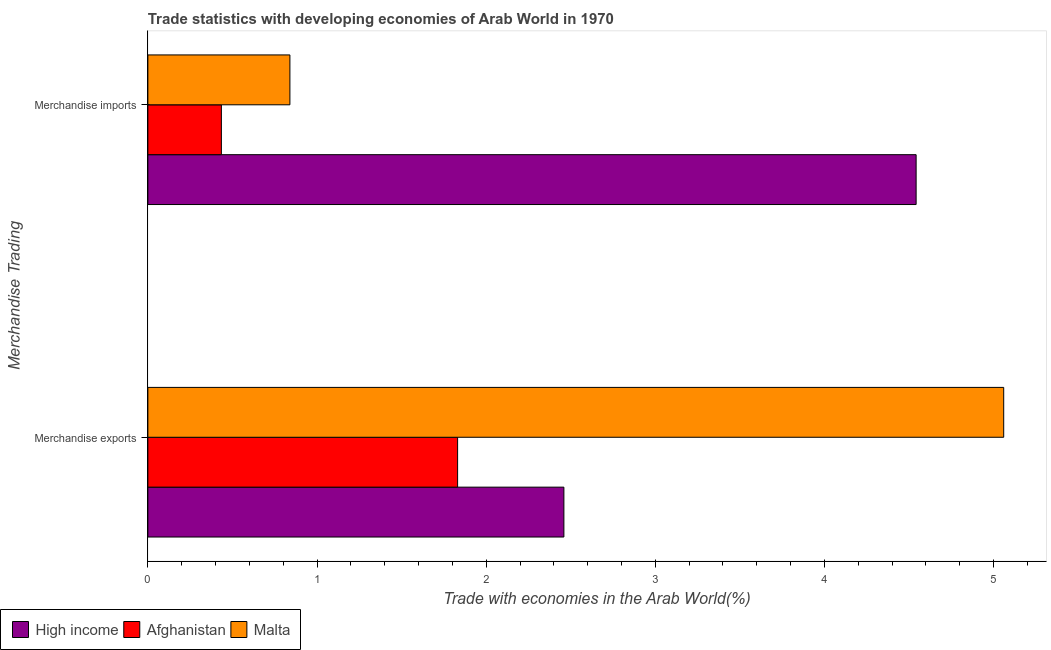Are the number of bars per tick equal to the number of legend labels?
Offer a terse response. Yes. Are the number of bars on each tick of the Y-axis equal?
Provide a short and direct response. Yes. How many bars are there on the 2nd tick from the bottom?
Keep it short and to the point. 3. What is the merchandise imports in Malta?
Provide a succinct answer. 0.84. Across all countries, what is the maximum merchandise imports?
Offer a terse response. 4.54. Across all countries, what is the minimum merchandise exports?
Provide a succinct answer. 1.83. In which country was the merchandise imports minimum?
Your answer should be very brief. Afghanistan. What is the total merchandise exports in the graph?
Your answer should be very brief. 9.35. What is the difference between the merchandise exports in High income and that in Afghanistan?
Your answer should be compact. 0.63. What is the difference between the merchandise exports in Afghanistan and the merchandise imports in Malta?
Give a very brief answer. 0.99. What is the average merchandise imports per country?
Offer a terse response. 1.94. What is the difference between the merchandise imports and merchandise exports in High income?
Provide a succinct answer. 2.08. In how many countries, is the merchandise imports greater than 0.2 %?
Make the answer very short. 3. What is the ratio of the merchandise exports in Afghanistan to that in Malta?
Provide a short and direct response. 0.36. In how many countries, is the merchandise exports greater than the average merchandise exports taken over all countries?
Your response must be concise. 1. What does the 1st bar from the top in Merchandise imports represents?
Provide a succinct answer. Malta. How many bars are there?
Provide a short and direct response. 6. How many countries are there in the graph?
Provide a short and direct response. 3. What is the difference between two consecutive major ticks on the X-axis?
Ensure brevity in your answer.  1. Does the graph contain grids?
Keep it short and to the point. No. Where does the legend appear in the graph?
Offer a very short reply. Bottom left. How are the legend labels stacked?
Keep it short and to the point. Horizontal. What is the title of the graph?
Provide a succinct answer. Trade statistics with developing economies of Arab World in 1970. Does "Jordan" appear as one of the legend labels in the graph?
Provide a short and direct response. No. What is the label or title of the X-axis?
Your answer should be compact. Trade with economies in the Arab World(%). What is the label or title of the Y-axis?
Offer a very short reply. Merchandise Trading. What is the Trade with economies in the Arab World(%) of High income in Merchandise exports?
Your response must be concise. 2.46. What is the Trade with economies in the Arab World(%) in Afghanistan in Merchandise exports?
Your answer should be compact. 1.83. What is the Trade with economies in the Arab World(%) in Malta in Merchandise exports?
Provide a short and direct response. 5.06. What is the Trade with economies in the Arab World(%) in High income in Merchandise imports?
Your response must be concise. 4.54. What is the Trade with economies in the Arab World(%) of Afghanistan in Merchandise imports?
Keep it short and to the point. 0.43. What is the Trade with economies in the Arab World(%) in Malta in Merchandise imports?
Keep it short and to the point. 0.84. Across all Merchandise Trading, what is the maximum Trade with economies in the Arab World(%) in High income?
Provide a short and direct response. 4.54. Across all Merchandise Trading, what is the maximum Trade with economies in the Arab World(%) of Afghanistan?
Your response must be concise. 1.83. Across all Merchandise Trading, what is the maximum Trade with economies in the Arab World(%) of Malta?
Your answer should be compact. 5.06. Across all Merchandise Trading, what is the minimum Trade with economies in the Arab World(%) in High income?
Provide a short and direct response. 2.46. Across all Merchandise Trading, what is the minimum Trade with economies in the Arab World(%) in Afghanistan?
Keep it short and to the point. 0.43. Across all Merchandise Trading, what is the minimum Trade with economies in the Arab World(%) in Malta?
Provide a short and direct response. 0.84. What is the total Trade with economies in the Arab World(%) of High income in the graph?
Provide a succinct answer. 7. What is the total Trade with economies in the Arab World(%) in Afghanistan in the graph?
Keep it short and to the point. 2.27. What is the total Trade with economies in the Arab World(%) of Malta in the graph?
Provide a short and direct response. 5.9. What is the difference between the Trade with economies in the Arab World(%) of High income in Merchandise exports and that in Merchandise imports?
Make the answer very short. -2.08. What is the difference between the Trade with economies in the Arab World(%) of Afghanistan in Merchandise exports and that in Merchandise imports?
Give a very brief answer. 1.4. What is the difference between the Trade with economies in the Arab World(%) in Malta in Merchandise exports and that in Merchandise imports?
Provide a short and direct response. 4.22. What is the difference between the Trade with economies in the Arab World(%) of High income in Merchandise exports and the Trade with economies in the Arab World(%) of Afghanistan in Merchandise imports?
Offer a very short reply. 2.02. What is the difference between the Trade with economies in the Arab World(%) in High income in Merchandise exports and the Trade with economies in the Arab World(%) in Malta in Merchandise imports?
Your answer should be very brief. 1.62. What is the difference between the Trade with economies in the Arab World(%) of Afghanistan in Merchandise exports and the Trade with economies in the Arab World(%) of Malta in Merchandise imports?
Your response must be concise. 0.99. What is the average Trade with economies in the Arab World(%) of High income per Merchandise Trading?
Offer a terse response. 3.5. What is the average Trade with economies in the Arab World(%) of Afghanistan per Merchandise Trading?
Offer a terse response. 1.13. What is the average Trade with economies in the Arab World(%) of Malta per Merchandise Trading?
Make the answer very short. 2.95. What is the difference between the Trade with economies in the Arab World(%) of High income and Trade with economies in the Arab World(%) of Afghanistan in Merchandise exports?
Offer a terse response. 0.63. What is the difference between the Trade with economies in the Arab World(%) in High income and Trade with economies in the Arab World(%) in Malta in Merchandise exports?
Ensure brevity in your answer.  -2.6. What is the difference between the Trade with economies in the Arab World(%) of Afghanistan and Trade with economies in the Arab World(%) of Malta in Merchandise exports?
Provide a succinct answer. -3.23. What is the difference between the Trade with economies in the Arab World(%) of High income and Trade with economies in the Arab World(%) of Afghanistan in Merchandise imports?
Ensure brevity in your answer.  4.11. What is the difference between the Trade with economies in the Arab World(%) in High income and Trade with economies in the Arab World(%) in Malta in Merchandise imports?
Ensure brevity in your answer.  3.7. What is the difference between the Trade with economies in the Arab World(%) of Afghanistan and Trade with economies in the Arab World(%) of Malta in Merchandise imports?
Make the answer very short. -0.41. What is the ratio of the Trade with economies in the Arab World(%) of High income in Merchandise exports to that in Merchandise imports?
Provide a short and direct response. 0.54. What is the ratio of the Trade with economies in the Arab World(%) of Afghanistan in Merchandise exports to that in Merchandise imports?
Keep it short and to the point. 4.21. What is the ratio of the Trade with economies in the Arab World(%) in Malta in Merchandise exports to that in Merchandise imports?
Keep it short and to the point. 6.03. What is the difference between the highest and the second highest Trade with economies in the Arab World(%) in High income?
Offer a terse response. 2.08. What is the difference between the highest and the second highest Trade with economies in the Arab World(%) of Afghanistan?
Your response must be concise. 1.4. What is the difference between the highest and the second highest Trade with economies in the Arab World(%) in Malta?
Make the answer very short. 4.22. What is the difference between the highest and the lowest Trade with economies in the Arab World(%) in High income?
Ensure brevity in your answer.  2.08. What is the difference between the highest and the lowest Trade with economies in the Arab World(%) of Afghanistan?
Your answer should be very brief. 1.4. What is the difference between the highest and the lowest Trade with economies in the Arab World(%) in Malta?
Your response must be concise. 4.22. 